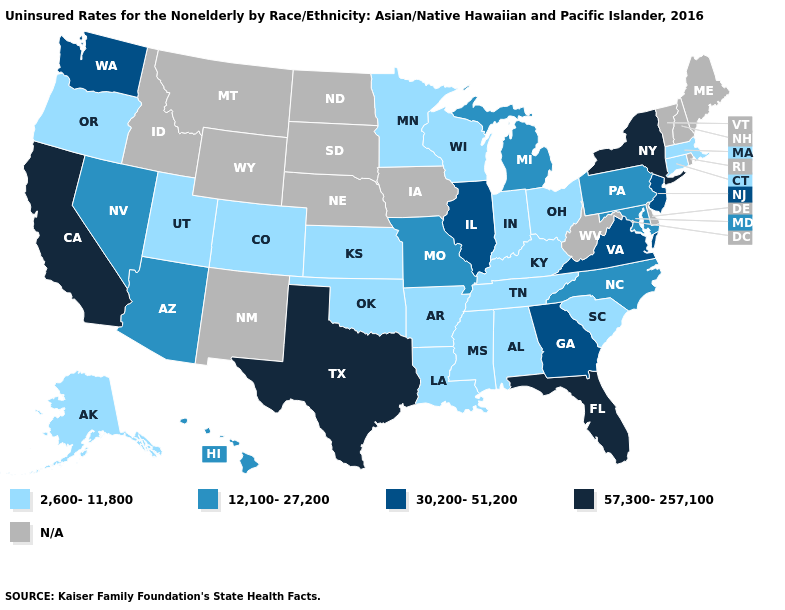Among the states that border Indiana , which have the highest value?
Keep it brief. Illinois. What is the lowest value in the MidWest?
Keep it brief. 2,600-11,800. What is the value of Kentucky?
Answer briefly. 2,600-11,800. Name the states that have a value in the range 30,200-51,200?
Write a very short answer. Georgia, Illinois, New Jersey, Virginia, Washington. What is the highest value in the West ?
Answer briefly. 57,300-257,100. Is the legend a continuous bar?
Answer briefly. No. Name the states that have a value in the range 30,200-51,200?
Quick response, please. Georgia, Illinois, New Jersey, Virginia, Washington. Is the legend a continuous bar?
Quick response, please. No. Among the states that border Georgia , which have the lowest value?
Keep it brief. Alabama, South Carolina, Tennessee. Among the states that border North Carolina , which have the lowest value?
Keep it brief. South Carolina, Tennessee. Does Indiana have the highest value in the MidWest?
Give a very brief answer. No. Is the legend a continuous bar?
Answer briefly. No. What is the value of Delaware?
Concise answer only. N/A. What is the lowest value in the USA?
Keep it brief. 2,600-11,800. Among the states that border Utah , does Colorado have the highest value?
Write a very short answer. No. 